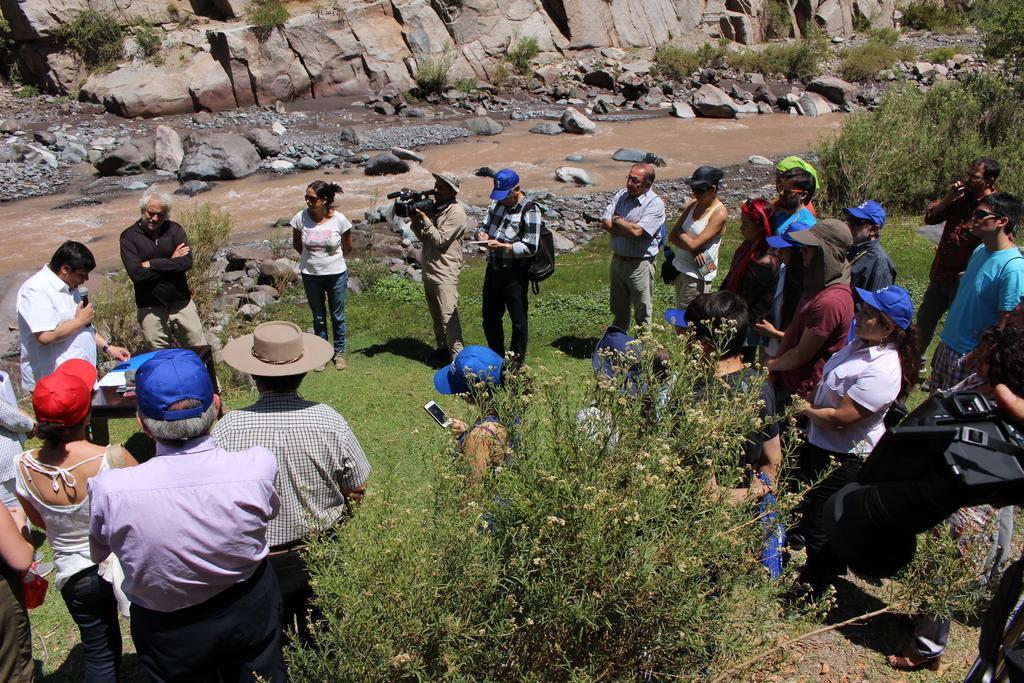How would you summarize this image in a sentence or two? This is the man standing and holding the mike. This looks like a table with few objects on it. I can see group of people standing. This person is holding a video recorder in his hands. These are the trees and small bushes. This looks like a river with the water flowing. I can see the rocks. I think this is the hill. Here is the grass. 